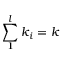Convert formula to latex. <formula><loc_0><loc_0><loc_500><loc_500>\sum _ { 1 } ^ { l } k _ { i } = k</formula> 